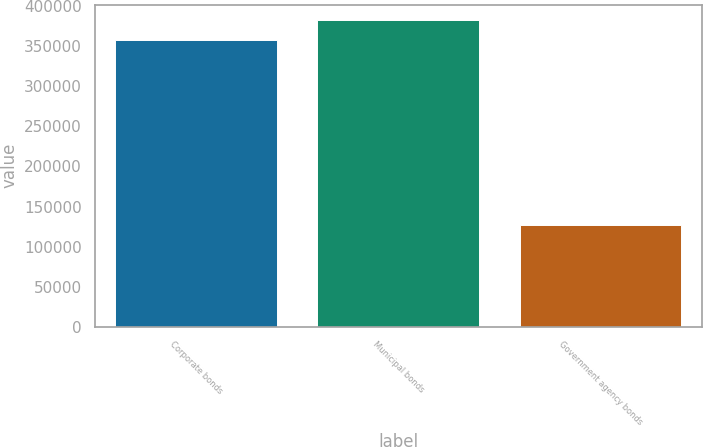Convert chart to OTSL. <chart><loc_0><loc_0><loc_500><loc_500><bar_chart><fcel>Corporate bonds<fcel>Municipal bonds<fcel>Government agency bonds<nl><fcel>357351<fcel>382459<fcel>126818<nl></chart> 